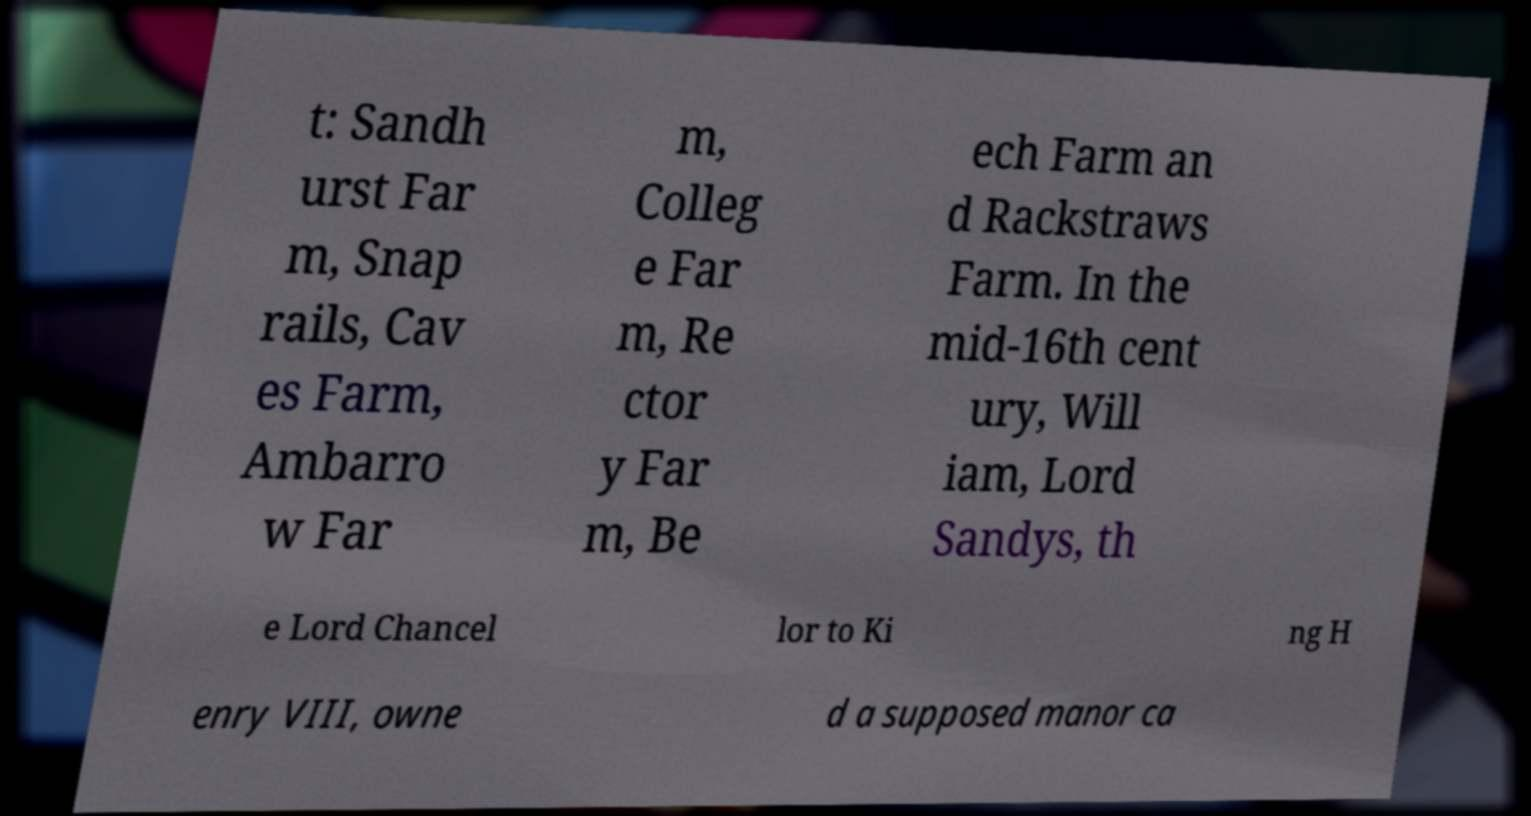I need the written content from this picture converted into text. Can you do that? t: Sandh urst Far m, Snap rails, Cav es Farm, Ambarro w Far m, Colleg e Far m, Re ctor y Far m, Be ech Farm an d Rackstraws Farm. In the mid-16th cent ury, Will iam, Lord Sandys, th e Lord Chancel lor to Ki ng H enry VIII, owne d a supposed manor ca 